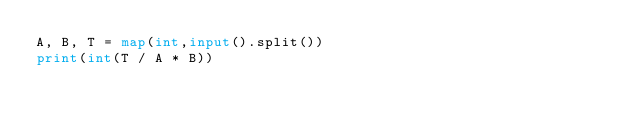Convert code to text. <code><loc_0><loc_0><loc_500><loc_500><_Python_>A, B, T = map(int,input().split())
print(int(T / A * B))</code> 